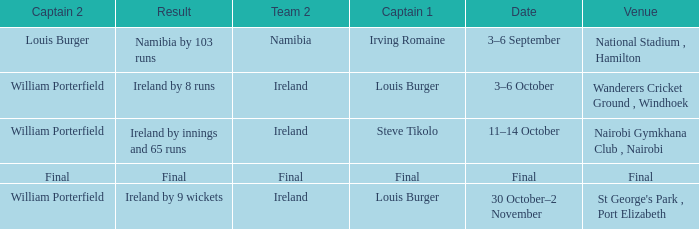Which Team 2 has a Captain 1 of final? Final. 